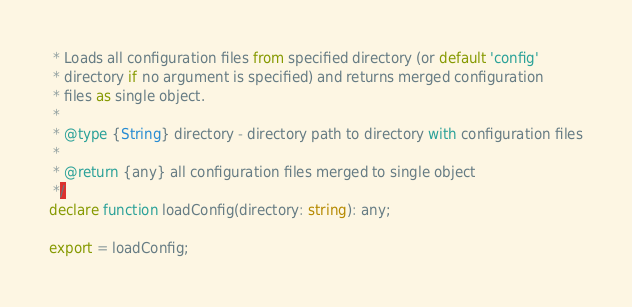Convert code to text. <code><loc_0><loc_0><loc_500><loc_500><_TypeScript_> * Loads all configuration files from specified directory (or default 'config'
 * directory if no argument is specified) and returns merged configuration
 * files as single object.
 *
 * @type {String} directory - directory path to directory with configuration files
 *
 * @return {any} all configuration files merged to single object
 */
declare function loadConfig(directory: string): any;

export = loadConfig;
</code> 